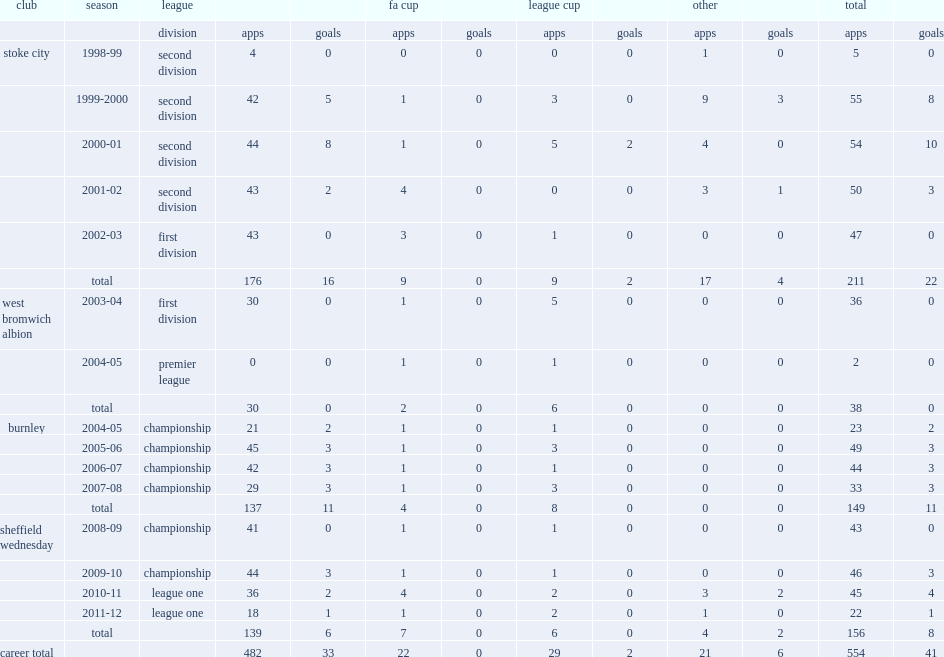Would you be able to parse every entry in this table? {'header': ['club', 'season', 'league', '', '', 'fa cup', '', 'league cup', '', 'other', '', 'total', ''], 'rows': [['', '', 'division', 'apps', 'goals', 'apps', 'goals', 'apps', 'goals', 'apps', 'goals', 'apps', 'goals'], ['stoke city', '1998-99', 'second division', '4', '0', '0', '0', '0', '0', '1', '0', '5', '0'], ['', '1999-2000', 'second division', '42', '5', '1', '0', '3', '0', '9', '3', '55', '8'], ['', '2000-01', 'second division', '44', '8', '1', '0', '5', '2', '4', '0', '54', '10'], ['', '2001-02', 'second division', '43', '2', '4', '0', '0', '0', '3', '1', '50', '3'], ['', '2002-03', 'first division', '43', '0', '3', '0', '1', '0', '0', '0', '47', '0'], ['', 'total', '', '176', '16', '9', '0', '9', '2', '17', '4', '211', '22'], ['west bromwich albion', '2003-04', 'first division', '30', '0', '1', '0', '5', '0', '0', '0', '36', '0'], ['', '2004-05', 'premier league', '0', '0', '1', '0', '1', '0', '0', '0', '2', '0'], ['', 'total', '', '30', '0', '2', '0', '6', '0', '0', '0', '38', '0'], ['burnley', '2004-05', 'championship', '21', '2', '1', '0', '1', '0', '0', '0', '23', '2'], ['', '2005-06', 'championship', '45', '3', '1', '0', '3', '0', '0', '0', '49', '3'], ['', '2006-07', 'championship', '42', '3', '1', '0', '1', '0', '0', '0', '44', '3'], ['', '2007-08', 'championship', '29', '3', '1', '0', '3', '0', '0', '0', '33', '3'], ['', 'total', '', '137', '11', '4', '0', '8', '0', '0', '0', '149', '11'], ['sheffield wednesday', '2008-09', 'championship', '41', '0', '1', '0', '1', '0', '0', '0', '43', '0'], ['', '2009-10', 'championship', '44', '3', '1', '0', '1', '0', '0', '0', '46', '3'], ['', '2010-11', 'league one', '36', '2', '4', '0', '2', '0', '3', '2', '45', '4'], ['', '2011-12', 'league one', '18', '1', '1', '0', '2', '0', '1', '0', '22', '1'], ['', 'total', '', '139', '6', '7', '0', '6', '0', '4', '2', '156', '8'], ['career total', '', '', '482', '33', '22', '0', '29', '2', '21', '6', '554', '41']]} How many games did o'connor play in four seasons at the club? 149.0. 